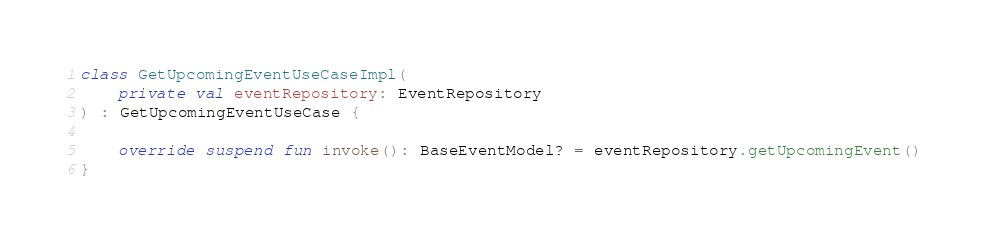Convert code to text. <code><loc_0><loc_0><loc_500><loc_500><_Kotlin_>
class GetUpcomingEventUseCaseImpl(
    private val eventRepository: EventRepository
) : GetUpcomingEventUseCase {

    override suspend fun invoke(): BaseEventModel? = eventRepository.getUpcomingEvent()
}
</code> 